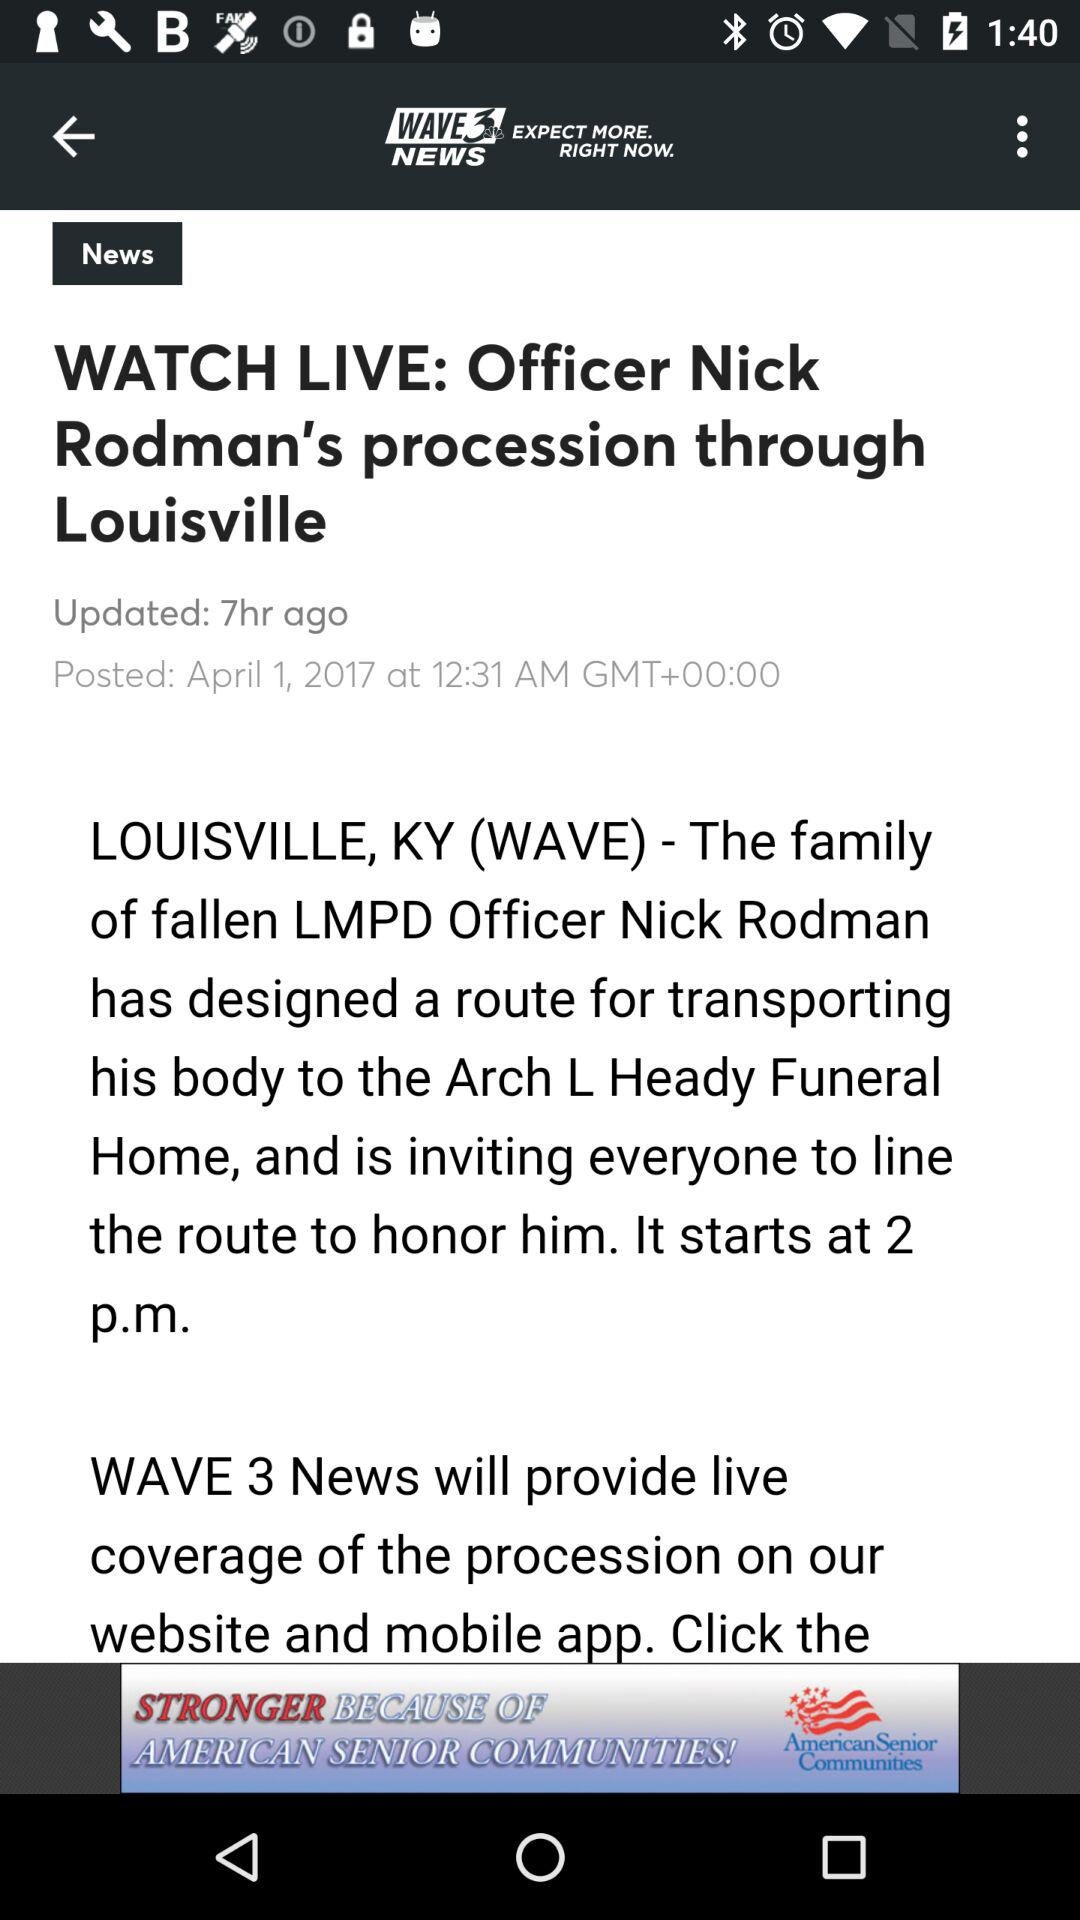When was the article posted? The article was posted on April 1, 2017 at 12:31 AM in Greenwich Mean Time. 